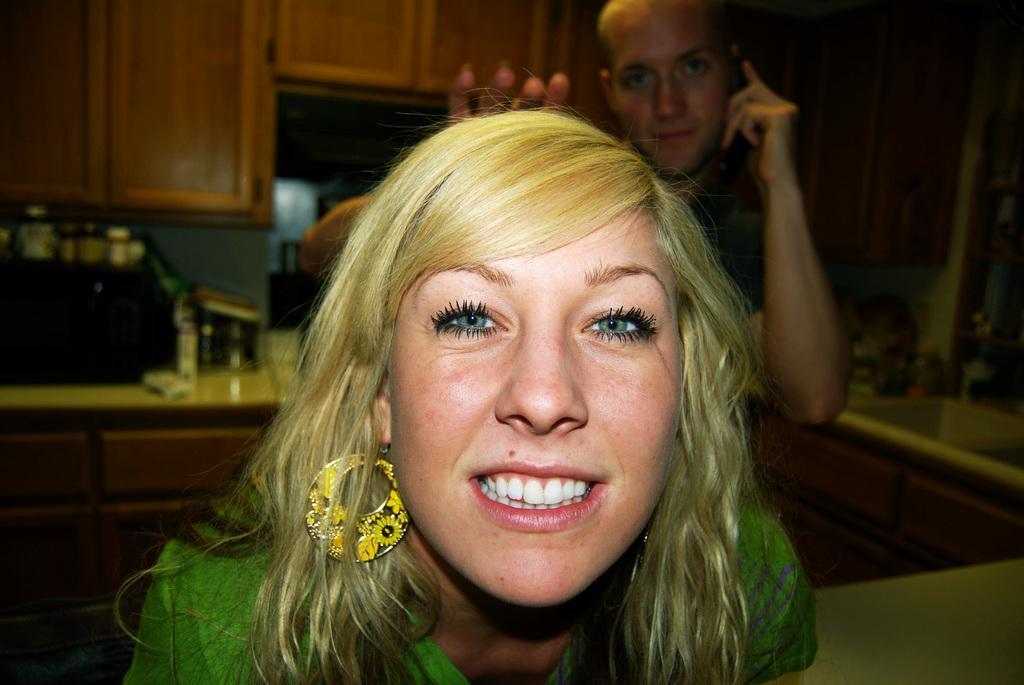Please provide a concise description of this image. In this image, we can see a woman, she is smiling, there is a person standing behind the woman, in the background, we can see some cupboards. 